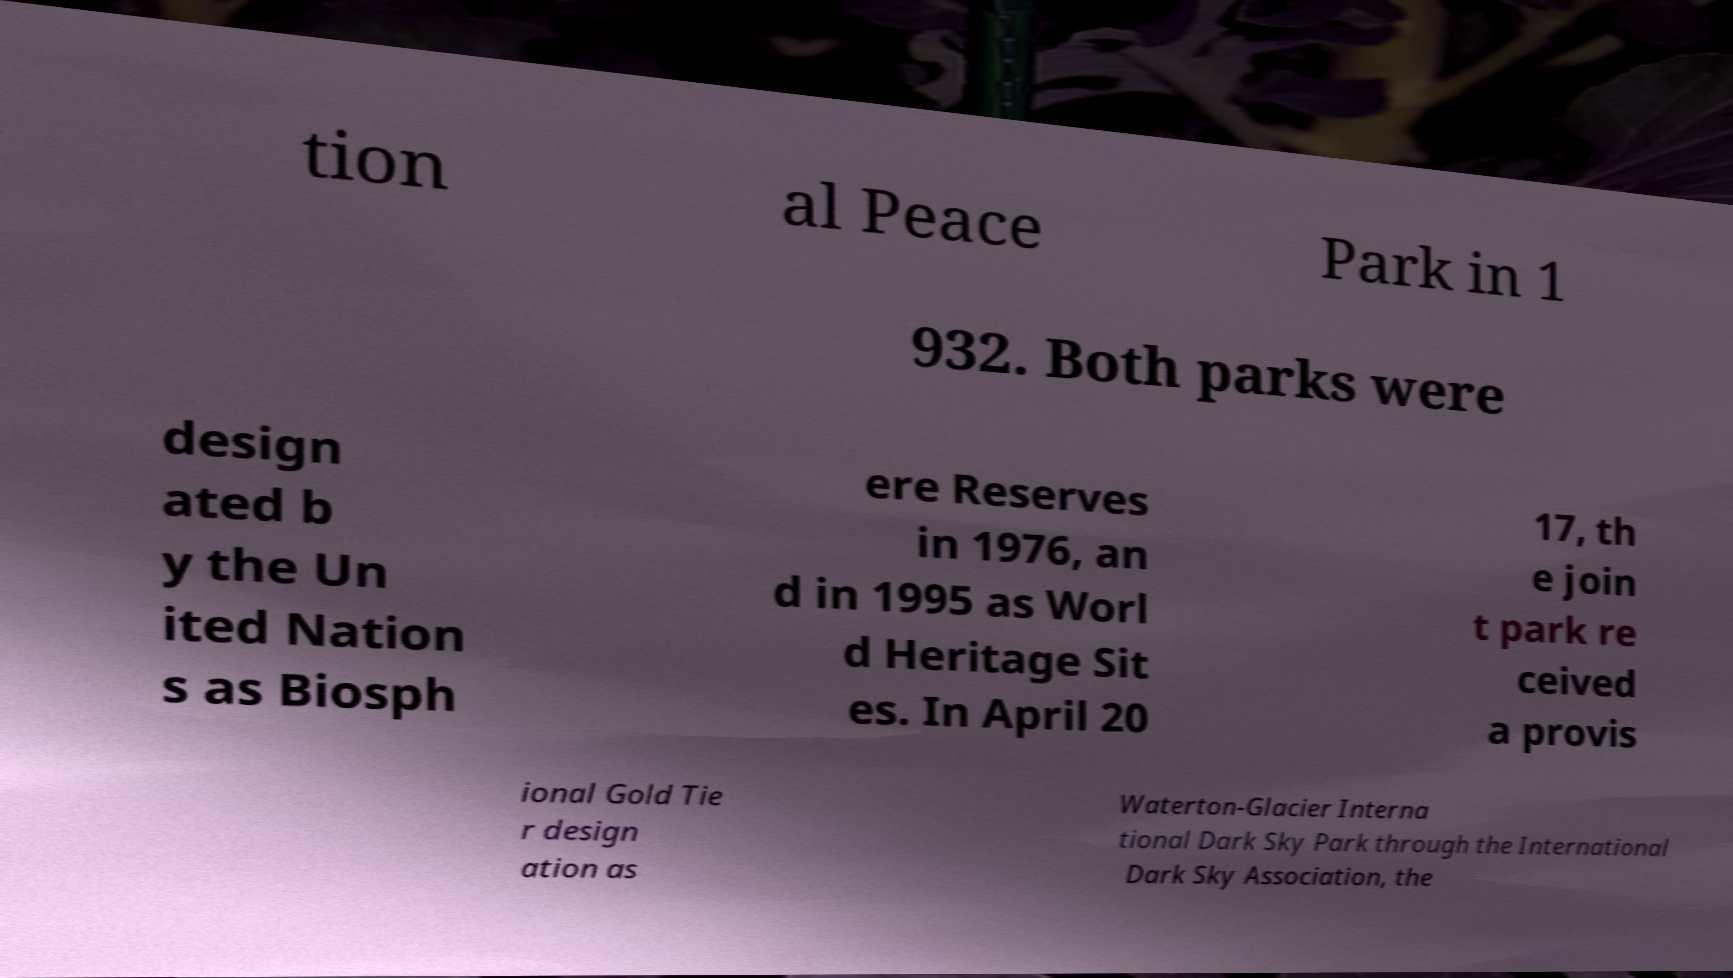What messages or text are displayed in this image? I need them in a readable, typed format. tion al Peace Park in 1 932. Both parks were design ated b y the Un ited Nation s as Biosph ere Reserves in 1976, an d in 1995 as Worl d Heritage Sit es. In April 20 17, th e join t park re ceived a provis ional Gold Tie r design ation as Waterton-Glacier Interna tional Dark Sky Park through the International Dark Sky Association, the 